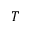<formula> <loc_0><loc_0><loc_500><loc_500>T</formula> 